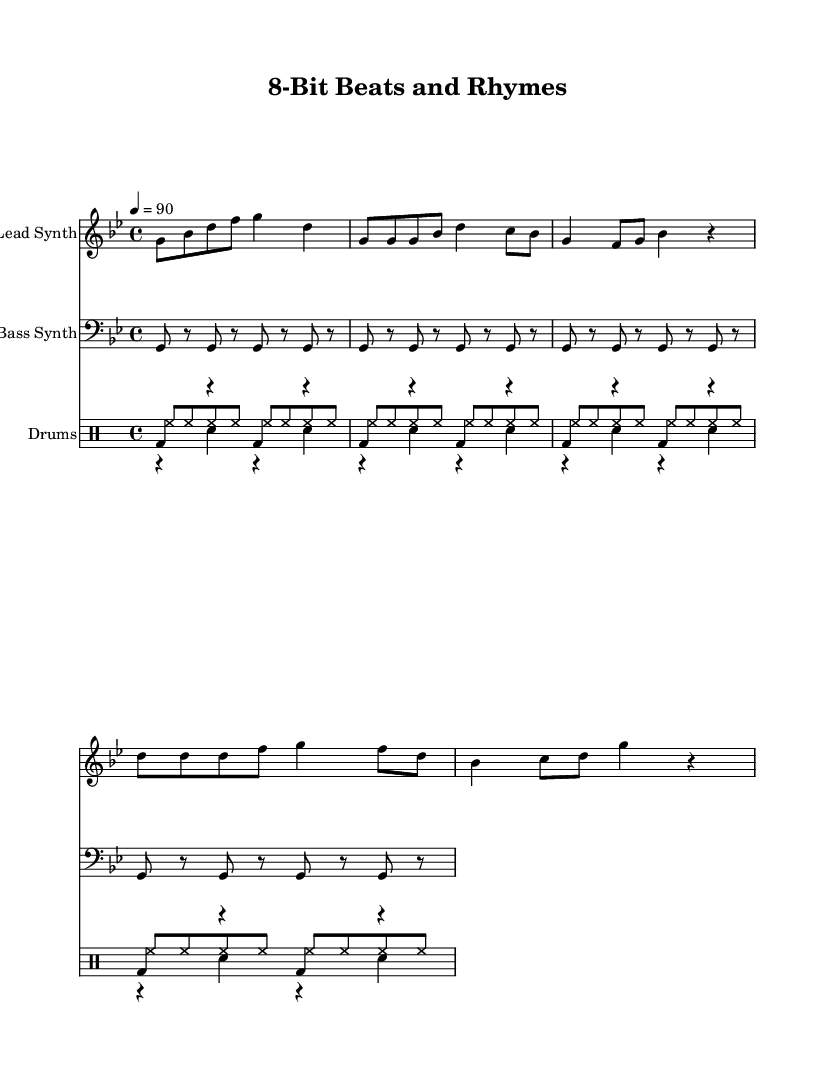What is the key signature of this music? The key signature is G minor, which has two flats (B♭ and E♭). This is indicated at the beginning of the staff.
Answer: G minor What is the time signature of this music? The time signature is 4/4, which means there are four beats per measure and the quarter note gets one beat. This is indicated at the start where the time is marked.
Answer: 4/4 What is the tempo marking of this piece? The tempo marking is 90 beats per minute, which indicates the speed at which the piece should be played. The tempo is explicitly stated in the header section.
Answer: 90 How many measures are in the lead synth part? There are a total of 8 measures in the lead synth part when counting each distinct grouping of notes. Each section of music typically averages 2 measures for the intro, verse, and chorus.
Answer: 8 Which instrument plays the bass line? The bass line is played by the "Bass Synth," as indicated in the staff labeling. This labeling defines which instrument corresponds to each musical line.
Answer: Bass Synth How many types of drums are used in this composition? There are three types of drums: kick drum, snare drum, and hi-hat, as denoted in the drum staff division. This shows the different sounds and rhythms used in the percussion part.
Answer: Three What instrument is used for the lead melody? The lead melody is played by the "Lead Synth," as specified in the staff composition. This identification is crucial to understand which instrument provides the main melodic line.
Answer: Lead Synth 